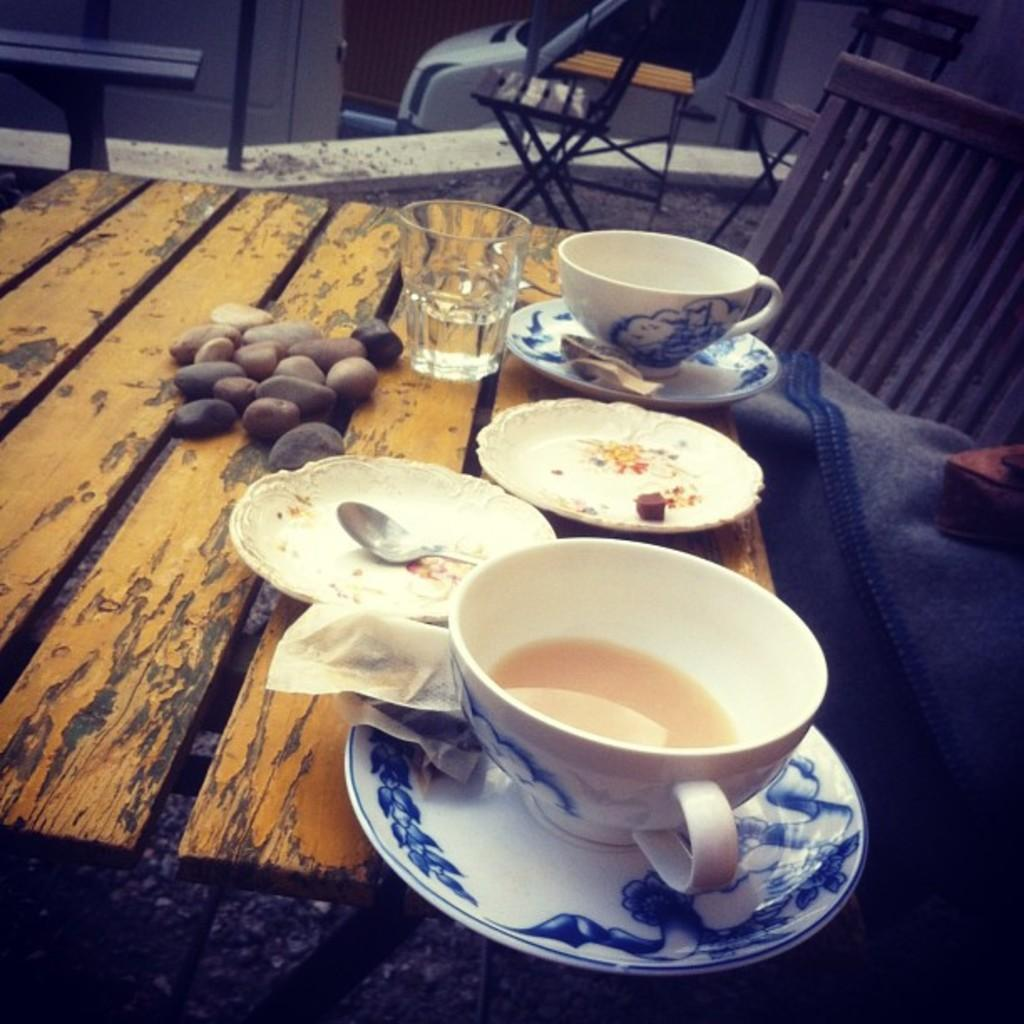What piece of furniture is present in the image? There is a table in the image. What items can be seen on the table? There are cups, plates, a spoon, a glass, and a stone on the table. Are there any chairs visible in the image? Yes, there are chairs in the background of the image. Can you see any toes on the table in the image? There are no toes present on the table in the image. Is there a basketball being used as a decoration on the table? There is no basketball present on the table in the image. 